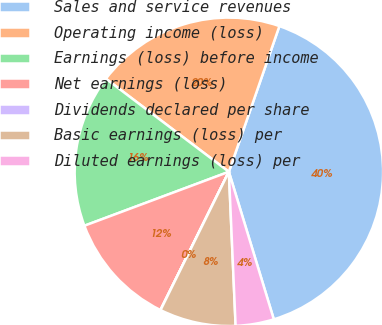Convert chart. <chart><loc_0><loc_0><loc_500><loc_500><pie_chart><fcel>Sales and service revenues<fcel>Operating income (loss)<fcel>Earnings (loss) before income<fcel>Net earnings (loss)<fcel>Dividends declared per share<fcel>Basic earnings (loss) per<fcel>Diluted earnings (loss) per<nl><fcel>39.98%<fcel>20.0%<fcel>16.0%<fcel>12.0%<fcel>0.01%<fcel>8.0%<fcel>4.01%<nl></chart> 